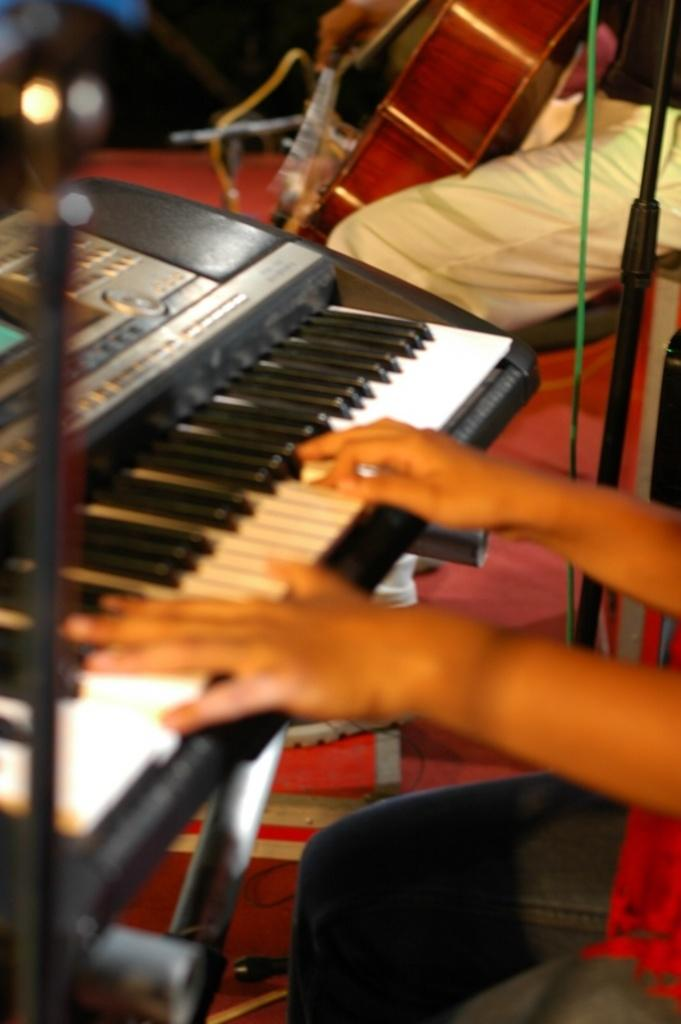What is the human hand in the image doing? The human hand in the image is playing a piano. What other musical instrument is present in the image? There is a person holding a guitar in the image. What type of insect can be seen playing the piano in the image? There is no insect present in the image, and therefore no such activity can be observed. 